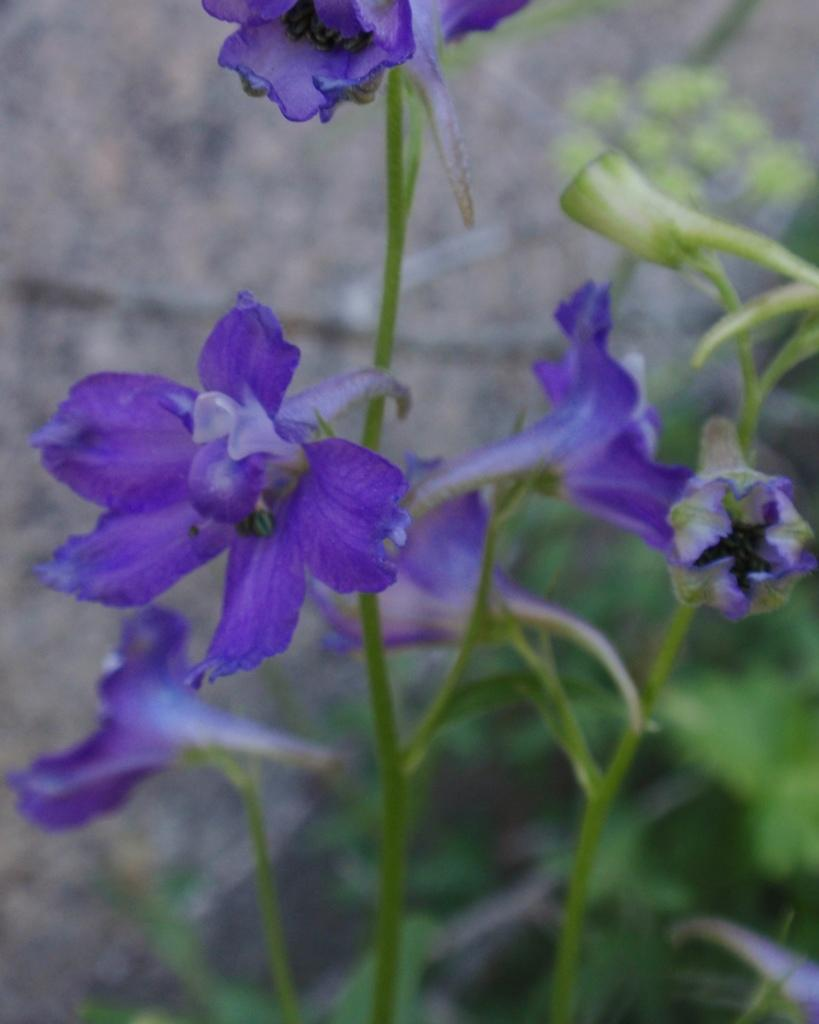What type of plant can be seen in the image? There is a plant with flowers present in the image. Can you describe the background of the image? The background of the image is blurred. What type of salt can be seen on the plant in the image? There is no salt present on the plant in the image. How does the plant taste in the image? The image does not provide any information about the taste of the plant. 